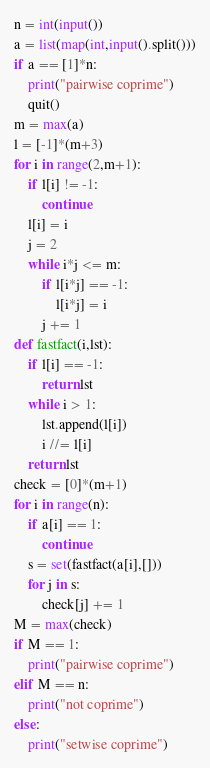<code> <loc_0><loc_0><loc_500><loc_500><_Python_>n = int(input())
a = list(map(int,input().split()))
if a == [1]*n:
    print("pairwise coprime")
    quit()
m = max(a)
l = [-1]*(m+3)
for i in range(2,m+1):
    if l[i] != -1:
        continue
    l[i] = i
    j = 2
    while i*j <= m:
        if l[i*j] == -1:
            l[i*j] = i
        j += 1
def fastfact(i,lst):
    if l[i] == -1:
        return lst
    while i > 1:
        lst.append(l[i])
        i //= l[i]
    return lst
check = [0]*(m+1)
for i in range(n):
    if a[i] == 1:
        continue
    s = set(fastfact(a[i],[]))
    for j in s:
        check[j] += 1
M = max(check)
if M == 1:
    print("pairwise coprime")
elif M == n:
    print("not coprime")
else:
    print("setwise coprime")</code> 